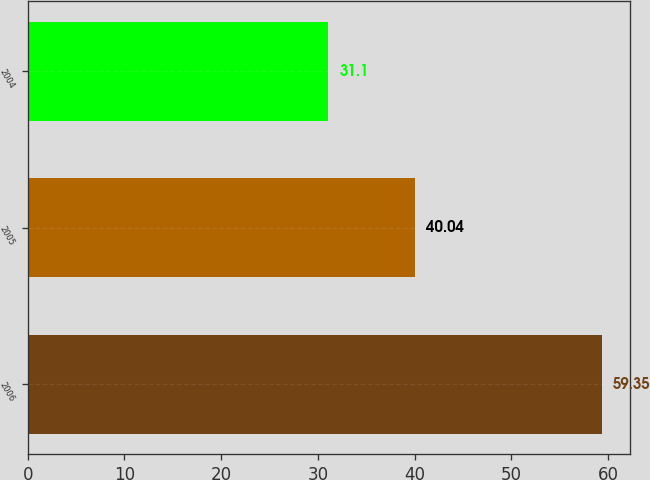<chart> <loc_0><loc_0><loc_500><loc_500><bar_chart><fcel>2006<fcel>2005<fcel>2004<nl><fcel>59.35<fcel>40.04<fcel>31.1<nl></chart> 